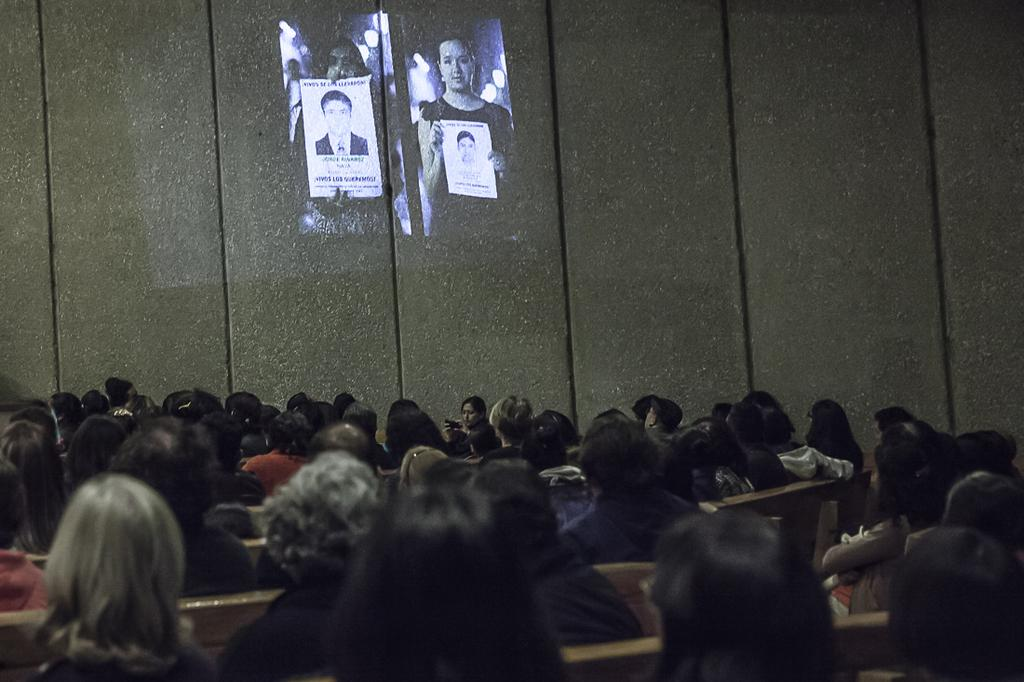What is the main subject of the image? The main subject of the image is a crowd sitting. What can be seen in the background of the image? There is a wall and a screen visible in the background of the image. How many horses are present in the image? There are no horses present in the image. What type of nerve is being stimulated by the crowd in the image? The image does not depict any activity that would stimulate a nerve. 